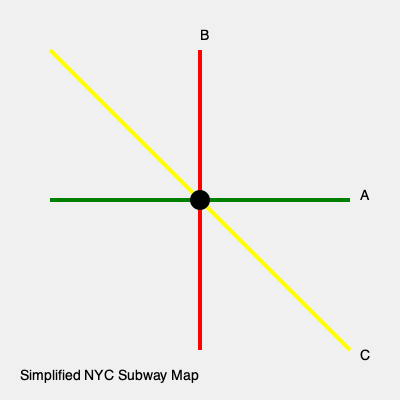Match the subway line colors to their routes on this simplified NYC subway map. Which line runs diagonally from the upper left to the lower right corner? To answer this question, let's analyze the simplified NYC subway map:

1. We see three distinct subway lines represented by different colors:
   - A horizontal green line running from left to right
   - A vertical red line running from top to bottom
   - A diagonal yellow line running from the upper left to the lower right

2. The question specifically asks about the line running diagonally from the upper left to the lower right corner.

3. By observing the map, we can clearly see that the yellow line is the one that matches this description.

4. In the actual NYC subway system, the diagonal yellow line could represent several routes, such as the N, Q, R, or W trains, which often run diagonally through Manhattan. However, for the purposes of this simplified map, we're focusing solely on the color and direction.

5. It's worth noting that while this is a simplified map, it does capture the essence of how subway lines often intersect in Manhattan, with some running horizontally (like the L train), some vertically (like parts of the 1, 2, 3 lines), and others diagonally.
Answer: Yellow line 